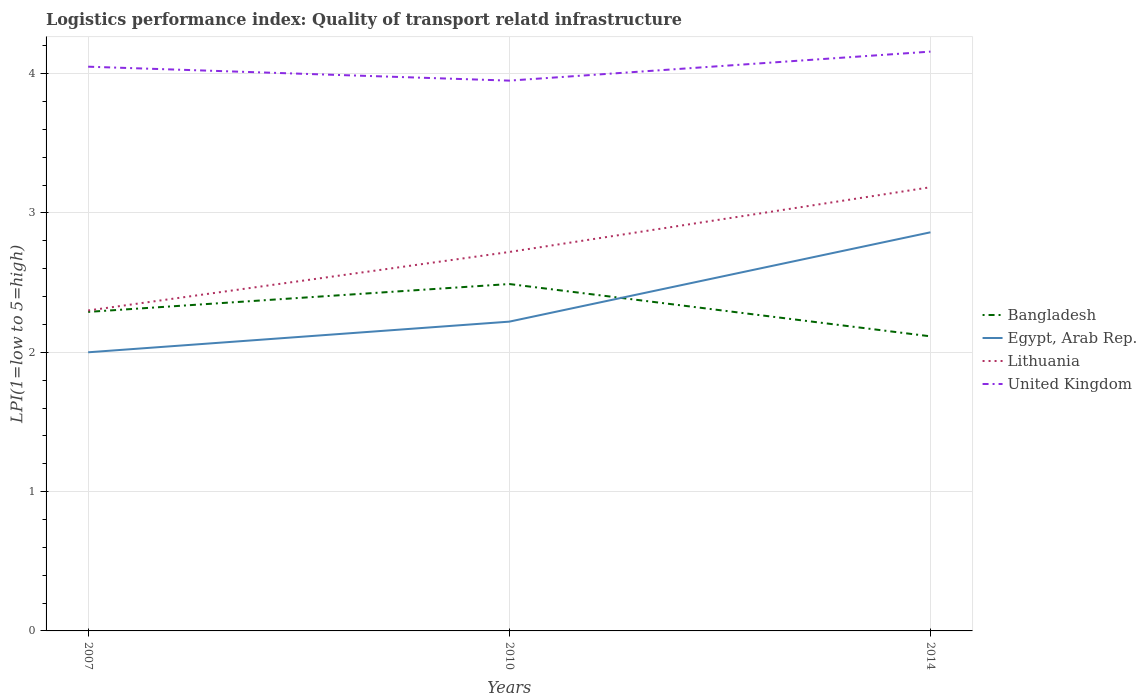How many different coloured lines are there?
Keep it short and to the point. 4. What is the total logistics performance index in Lithuania in the graph?
Provide a succinct answer. -0.42. What is the difference between the highest and the second highest logistics performance index in United Kingdom?
Your response must be concise. 0.21. What is the difference between the highest and the lowest logistics performance index in Egypt, Arab Rep.?
Provide a short and direct response. 1. How many lines are there?
Keep it short and to the point. 4. How many years are there in the graph?
Offer a very short reply. 3. What is the difference between two consecutive major ticks on the Y-axis?
Provide a short and direct response. 1. Are the values on the major ticks of Y-axis written in scientific E-notation?
Offer a terse response. No. Does the graph contain grids?
Your response must be concise. Yes. What is the title of the graph?
Your answer should be compact. Logistics performance index: Quality of transport relatd infrastructure. What is the label or title of the Y-axis?
Give a very brief answer. LPI(1=low to 5=high). What is the LPI(1=low to 5=high) in Bangladesh in 2007?
Give a very brief answer. 2.29. What is the LPI(1=low to 5=high) of United Kingdom in 2007?
Your answer should be very brief. 4.05. What is the LPI(1=low to 5=high) in Bangladesh in 2010?
Your response must be concise. 2.49. What is the LPI(1=low to 5=high) of Egypt, Arab Rep. in 2010?
Keep it short and to the point. 2.22. What is the LPI(1=low to 5=high) of Lithuania in 2010?
Ensure brevity in your answer.  2.72. What is the LPI(1=low to 5=high) in United Kingdom in 2010?
Provide a short and direct response. 3.95. What is the LPI(1=low to 5=high) in Bangladesh in 2014?
Keep it short and to the point. 2.11. What is the LPI(1=low to 5=high) of Egypt, Arab Rep. in 2014?
Your response must be concise. 2.86. What is the LPI(1=low to 5=high) of Lithuania in 2014?
Provide a short and direct response. 3.18. What is the LPI(1=low to 5=high) in United Kingdom in 2014?
Your response must be concise. 4.16. Across all years, what is the maximum LPI(1=low to 5=high) in Bangladesh?
Give a very brief answer. 2.49. Across all years, what is the maximum LPI(1=low to 5=high) in Egypt, Arab Rep.?
Keep it short and to the point. 2.86. Across all years, what is the maximum LPI(1=low to 5=high) in Lithuania?
Give a very brief answer. 3.18. Across all years, what is the maximum LPI(1=low to 5=high) of United Kingdom?
Provide a short and direct response. 4.16. Across all years, what is the minimum LPI(1=low to 5=high) in Bangladesh?
Offer a terse response. 2.11. Across all years, what is the minimum LPI(1=low to 5=high) in Lithuania?
Offer a terse response. 2.3. Across all years, what is the minimum LPI(1=low to 5=high) of United Kingdom?
Offer a terse response. 3.95. What is the total LPI(1=low to 5=high) in Bangladesh in the graph?
Your answer should be compact. 6.89. What is the total LPI(1=low to 5=high) in Egypt, Arab Rep. in the graph?
Provide a short and direct response. 7.08. What is the total LPI(1=low to 5=high) in Lithuania in the graph?
Make the answer very short. 8.2. What is the total LPI(1=low to 5=high) of United Kingdom in the graph?
Make the answer very short. 12.16. What is the difference between the LPI(1=low to 5=high) in Egypt, Arab Rep. in 2007 and that in 2010?
Give a very brief answer. -0.22. What is the difference between the LPI(1=low to 5=high) in Lithuania in 2007 and that in 2010?
Ensure brevity in your answer.  -0.42. What is the difference between the LPI(1=low to 5=high) in Bangladesh in 2007 and that in 2014?
Make the answer very short. 0.18. What is the difference between the LPI(1=low to 5=high) in Egypt, Arab Rep. in 2007 and that in 2014?
Your response must be concise. -0.86. What is the difference between the LPI(1=low to 5=high) of Lithuania in 2007 and that in 2014?
Offer a terse response. -0.88. What is the difference between the LPI(1=low to 5=high) in United Kingdom in 2007 and that in 2014?
Ensure brevity in your answer.  -0.11. What is the difference between the LPI(1=low to 5=high) of Bangladesh in 2010 and that in 2014?
Offer a terse response. 0.38. What is the difference between the LPI(1=low to 5=high) in Egypt, Arab Rep. in 2010 and that in 2014?
Provide a succinct answer. -0.64. What is the difference between the LPI(1=low to 5=high) in Lithuania in 2010 and that in 2014?
Your answer should be very brief. -0.46. What is the difference between the LPI(1=low to 5=high) in United Kingdom in 2010 and that in 2014?
Keep it short and to the point. -0.21. What is the difference between the LPI(1=low to 5=high) in Bangladesh in 2007 and the LPI(1=low to 5=high) in Egypt, Arab Rep. in 2010?
Your answer should be compact. 0.07. What is the difference between the LPI(1=low to 5=high) in Bangladesh in 2007 and the LPI(1=low to 5=high) in Lithuania in 2010?
Your answer should be compact. -0.43. What is the difference between the LPI(1=low to 5=high) in Bangladesh in 2007 and the LPI(1=low to 5=high) in United Kingdom in 2010?
Ensure brevity in your answer.  -1.66. What is the difference between the LPI(1=low to 5=high) of Egypt, Arab Rep. in 2007 and the LPI(1=low to 5=high) of Lithuania in 2010?
Offer a very short reply. -0.72. What is the difference between the LPI(1=low to 5=high) in Egypt, Arab Rep. in 2007 and the LPI(1=low to 5=high) in United Kingdom in 2010?
Your answer should be very brief. -1.95. What is the difference between the LPI(1=low to 5=high) of Lithuania in 2007 and the LPI(1=low to 5=high) of United Kingdom in 2010?
Give a very brief answer. -1.65. What is the difference between the LPI(1=low to 5=high) of Bangladesh in 2007 and the LPI(1=low to 5=high) of Egypt, Arab Rep. in 2014?
Make the answer very short. -0.57. What is the difference between the LPI(1=low to 5=high) in Bangladesh in 2007 and the LPI(1=low to 5=high) in Lithuania in 2014?
Keep it short and to the point. -0.89. What is the difference between the LPI(1=low to 5=high) of Bangladesh in 2007 and the LPI(1=low to 5=high) of United Kingdom in 2014?
Your answer should be compact. -1.87. What is the difference between the LPI(1=low to 5=high) of Egypt, Arab Rep. in 2007 and the LPI(1=low to 5=high) of Lithuania in 2014?
Your response must be concise. -1.18. What is the difference between the LPI(1=low to 5=high) in Egypt, Arab Rep. in 2007 and the LPI(1=low to 5=high) in United Kingdom in 2014?
Keep it short and to the point. -2.16. What is the difference between the LPI(1=low to 5=high) of Lithuania in 2007 and the LPI(1=low to 5=high) of United Kingdom in 2014?
Keep it short and to the point. -1.86. What is the difference between the LPI(1=low to 5=high) of Bangladesh in 2010 and the LPI(1=low to 5=high) of Egypt, Arab Rep. in 2014?
Your response must be concise. -0.37. What is the difference between the LPI(1=low to 5=high) of Bangladesh in 2010 and the LPI(1=low to 5=high) of Lithuania in 2014?
Ensure brevity in your answer.  -0.69. What is the difference between the LPI(1=low to 5=high) of Bangladesh in 2010 and the LPI(1=low to 5=high) of United Kingdom in 2014?
Provide a succinct answer. -1.67. What is the difference between the LPI(1=low to 5=high) in Egypt, Arab Rep. in 2010 and the LPI(1=low to 5=high) in Lithuania in 2014?
Give a very brief answer. -0.96. What is the difference between the LPI(1=low to 5=high) of Egypt, Arab Rep. in 2010 and the LPI(1=low to 5=high) of United Kingdom in 2014?
Your answer should be compact. -1.94. What is the difference between the LPI(1=low to 5=high) in Lithuania in 2010 and the LPI(1=low to 5=high) in United Kingdom in 2014?
Offer a terse response. -1.44. What is the average LPI(1=low to 5=high) in Bangladesh per year?
Your answer should be compact. 2.3. What is the average LPI(1=low to 5=high) of Egypt, Arab Rep. per year?
Keep it short and to the point. 2.36. What is the average LPI(1=low to 5=high) in Lithuania per year?
Provide a short and direct response. 2.73. What is the average LPI(1=low to 5=high) of United Kingdom per year?
Offer a very short reply. 4.05. In the year 2007, what is the difference between the LPI(1=low to 5=high) of Bangladesh and LPI(1=low to 5=high) of Egypt, Arab Rep.?
Your answer should be very brief. 0.29. In the year 2007, what is the difference between the LPI(1=low to 5=high) in Bangladesh and LPI(1=low to 5=high) in Lithuania?
Ensure brevity in your answer.  -0.01. In the year 2007, what is the difference between the LPI(1=low to 5=high) of Bangladesh and LPI(1=low to 5=high) of United Kingdom?
Make the answer very short. -1.76. In the year 2007, what is the difference between the LPI(1=low to 5=high) of Egypt, Arab Rep. and LPI(1=low to 5=high) of Lithuania?
Ensure brevity in your answer.  -0.3. In the year 2007, what is the difference between the LPI(1=low to 5=high) of Egypt, Arab Rep. and LPI(1=low to 5=high) of United Kingdom?
Make the answer very short. -2.05. In the year 2007, what is the difference between the LPI(1=low to 5=high) in Lithuania and LPI(1=low to 5=high) in United Kingdom?
Offer a very short reply. -1.75. In the year 2010, what is the difference between the LPI(1=low to 5=high) in Bangladesh and LPI(1=low to 5=high) in Egypt, Arab Rep.?
Make the answer very short. 0.27. In the year 2010, what is the difference between the LPI(1=low to 5=high) in Bangladesh and LPI(1=low to 5=high) in Lithuania?
Your answer should be very brief. -0.23. In the year 2010, what is the difference between the LPI(1=low to 5=high) in Bangladesh and LPI(1=low to 5=high) in United Kingdom?
Keep it short and to the point. -1.46. In the year 2010, what is the difference between the LPI(1=low to 5=high) in Egypt, Arab Rep. and LPI(1=low to 5=high) in Lithuania?
Provide a succinct answer. -0.5. In the year 2010, what is the difference between the LPI(1=low to 5=high) in Egypt, Arab Rep. and LPI(1=low to 5=high) in United Kingdom?
Keep it short and to the point. -1.73. In the year 2010, what is the difference between the LPI(1=low to 5=high) in Lithuania and LPI(1=low to 5=high) in United Kingdom?
Provide a succinct answer. -1.23. In the year 2014, what is the difference between the LPI(1=low to 5=high) of Bangladesh and LPI(1=low to 5=high) of Egypt, Arab Rep.?
Provide a succinct answer. -0.75. In the year 2014, what is the difference between the LPI(1=low to 5=high) in Bangladesh and LPI(1=low to 5=high) in Lithuania?
Provide a short and direct response. -1.07. In the year 2014, what is the difference between the LPI(1=low to 5=high) in Bangladesh and LPI(1=low to 5=high) in United Kingdom?
Provide a succinct answer. -2.04. In the year 2014, what is the difference between the LPI(1=low to 5=high) in Egypt, Arab Rep. and LPI(1=low to 5=high) in Lithuania?
Offer a terse response. -0.32. In the year 2014, what is the difference between the LPI(1=low to 5=high) of Egypt, Arab Rep. and LPI(1=low to 5=high) of United Kingdom?
Keep it short and to the point. -1.3. In the year 2014, what is the difference between the LPI(1=low to 5=high) of Lithuania and LPI(1=low to 5=high) of United Kingdom?
Ensure brevity in your answer.  -0.97. What is the ratio of the LPI(1=low to 5=high) of Bangladesh in 2007 to that in 2010?
Your response must be concise. 0.92. What is the ratio of the LPI(1=low to 5=high) of Egypt, Arab Rep. in 2007 to that in 2010?
Ensure brevity in your answer.  0.9. What is the ratio of the LPI(1=low to 5=high) in Lithuania in 2007 to that in 2010?
Provide a short and direct response. 0.85. What is the ratio of the LPI(1=low to 5=high) of United Kingdom in 2007 to that in 2010?
Keep it short and to the point. 1.03. What is the ratio of the LPI(1=low to 5=high) in Bangladesh in 2007 to that in 2014?
Provide a short and direct response. 1.08. What is the ratio of the LPI(1=low to 5=high) of Egypt, Arab Rep. in 2007 to that in 2014?
Give a very brief answer. 0.7. What is the ratio of the LPI(1=low to 5=high) of Lithuania in 2007 to that in 2014?
Provide a succinct answer. 0.72. What is the ratio of the LPI(1=low to 5=high) of United Kingdom in 2007 to that in 2014?
Your response must be concise. 0.97. What is the ratio of the LPI(1=low to 5=high) in Bangladesh in 2010 to that in 2014?
Provide a succinct answer. 1.18. What is the ratio of the LPI(1=low to 5=high) of Egypt, Arab Rep. in 2010 to that in 2014?
Give a very brief answer. 0.78. What is the ratio of the LPI(1=low to 5=high) in Lithuania in 2010 to that in 2014?
Offer a very short reply. 0.85. What is the ratio of the LPI(1=low to 5=high) in United Kingdom in 2010 to that in 2014?
Make the answer very short. 0.95. What is the difference between the highest and the second highest LPI(1=low to 5=high) of Bangladesh?
Your answer should be compact. 0.2. What is the difference between the highest and the second highest LPI(1=low to 5=high) in Egypt, Arab Rep.?
Keep it short and to the point. 0.64. What is the difference between the highest and the second highest LPI(1=low to 5=high) of Lithuania?
Your answer should be very brief. 0.46. What is the difference between the highest and the second highest LPI(1=low to 5=high) of United Kingdom?
Provide a short and direct response. 0.11. What is the difference between the highest and the lowest LPI(1=low to 5=high) of Bangladesh?
Offer a terse response. 0.38. What is the difference between the highest and the lowest LPI(1=low to 5=high) in Egypt, Arab Rep.?
Your answer should be compact. 0.86. What is the difference between the highest and the lowest LPI(1=low to 5=high) of Lithuania?
Your response must be concise. 0.88. What is the difference between the highest and the lowest LPI(1=low to 5=high) of United Kingdom?
Make the answer very short. 0.21. 